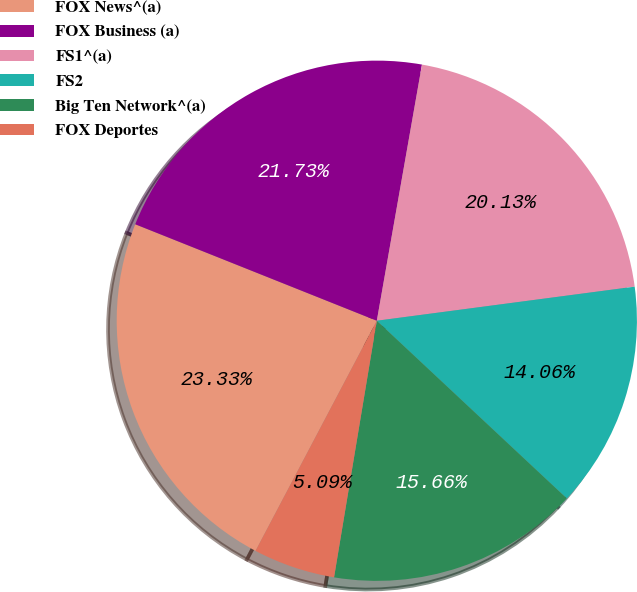Convert chart to OTSL. <chart><loc_0><loc_0><loc_500><loc_500><pie_chart><fcel>FOX News^(a)<fcel>FOX Business (a)<fcel>FS1^(a)<fcel>FS2<fcel>Big Ten Network^(a)<fcel>FOX Deportes<nl><fcel>23.33%<fcel>21.73%<fcel>20.13%<fcel>14.06%<fcel>15.66%<fcel>5.09%<nl></chart> 